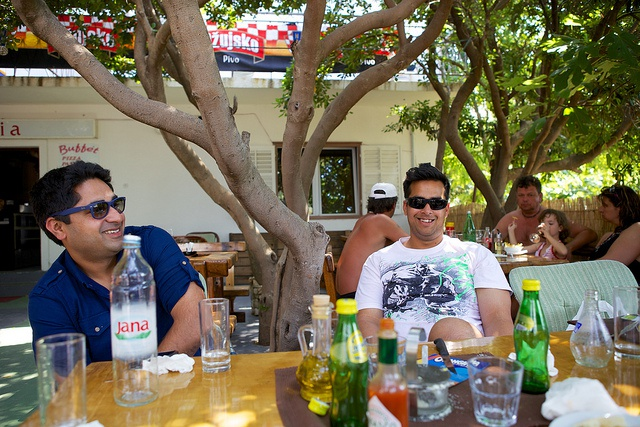Describe the objects in this image and their specific colors. I can see dining table in black, gray, tan, olive, and lightgray tones, people in black, navy, brown, and gray tones, people in black, lavender, gray, and darkgray tones, bottle in black, lightgray, darkgray, gray, and tan tones, and chair in black, darkgray, gray, and lightblue tones in this image. 